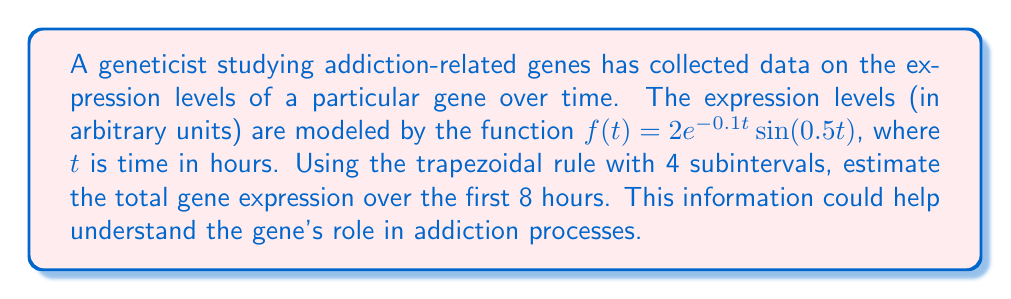Could you help me with this problem? To estimate the total gene expression, we need to calculate the integral of $f(t)$ from 0 to 8 using the trapezoidal rule with 4 subintervals.

Step 1: Divide the interval [0, 8] into 4 equal subintervals.
Subinterval width: $h = \frac{8-0}{4} = 2$

Step 2: Calculate the function values at each point:
$t_0 = 0$: $f(0) = 2e^{-0.1(0)}\sin(0.5(0)) = 0$
$t_1 = 2$: $f(2) = 2e^{-0.1(2)}\sin(0.5(2)) \approx 1.6284$
$t_2 = 4$: $f(4) = 2e^{-0.1(4)}\sin(0.5(4)) \approx 0.9735$
$t_3 = 6$: $f(6) = 2e^{-0.1(6)}\sin(0.5(6)) \approx -0.2361$
$t_4 = 8$: $f(8) = 2e^{-0.1(8)}\sin(0.5(8)) \approx -0.8786$

Step 3: Apply the trapezoidal rule formula:
$$\int_a^b f(x)dx \approx \frac{h}{2}[f(x_0) + 2f(x_1) + 2f(x_2) + ... + 2f(x_{n-1}) + f(x_n)]$$

$$\int_0^8 f(t)dt \approx \frac{2}{2}[f(0) + 2f(2) + 2f(4) + 2f(6) + f(8)]$$

Step 4: Substitute the values:
$$\int_0^8 f(t)dt \approx 1[0 + 2(1.6284) + 2(0.9735) + 2(-0.2361) + (-0.8786)]$$

Step 5: Calculate the result:
$$\int_0^8 f(t)dt \approx 1[3.2568 + 1.9470 - 0.4722 - 0.8786] \approx 3.8530$$
Answer: 3.8530 